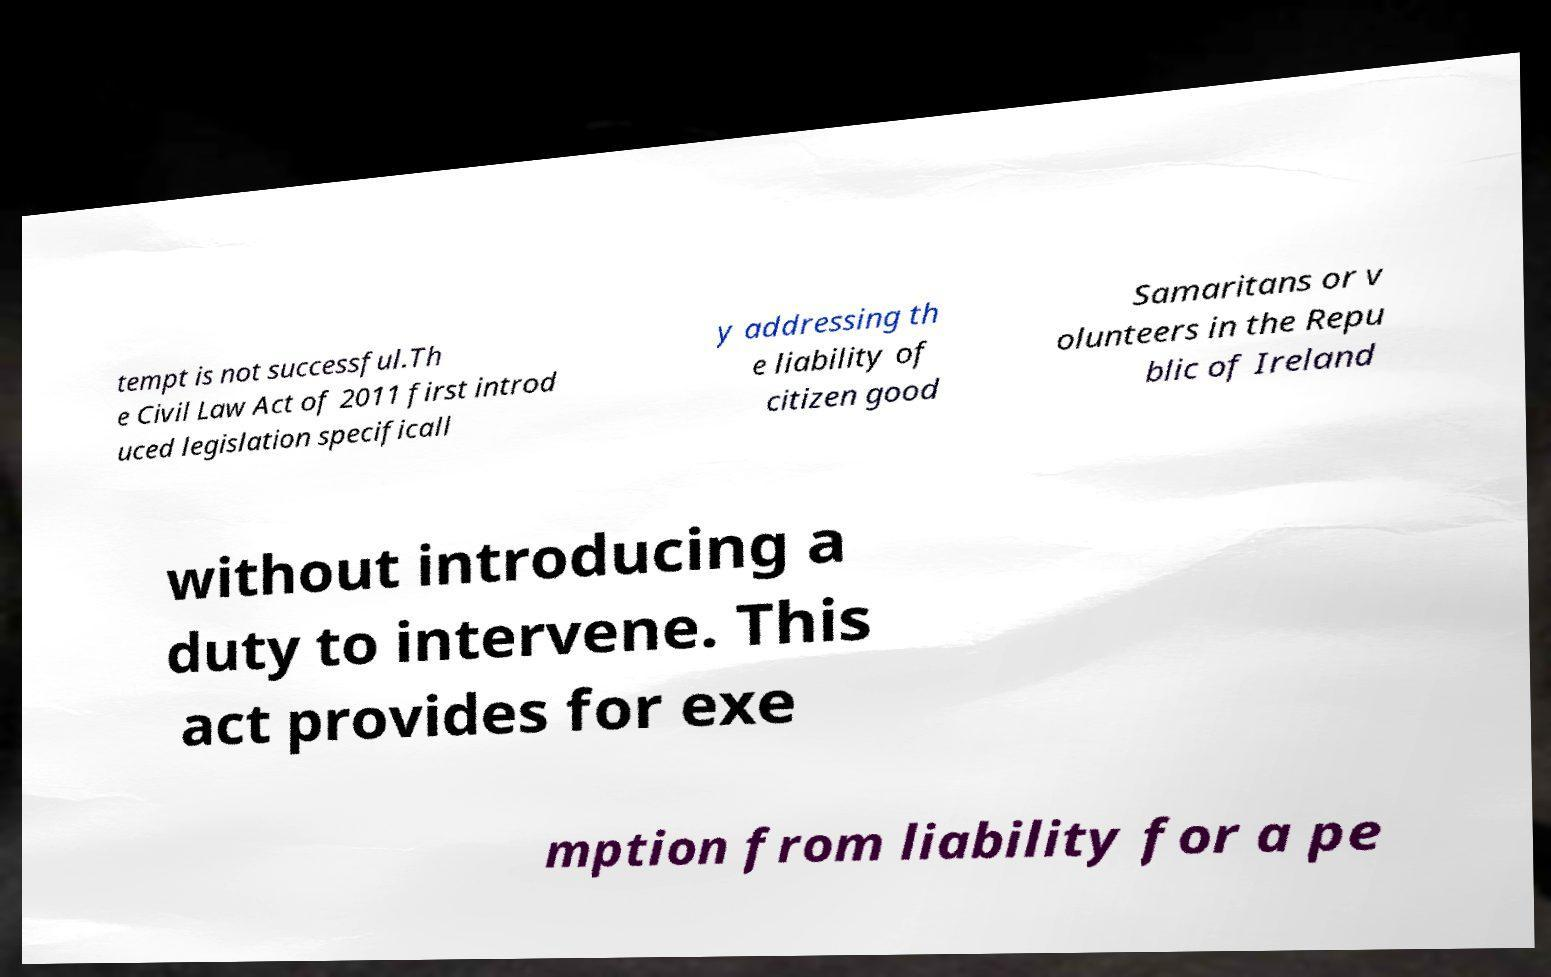I need the written content from this picture converted into text. Can you do that? tempt is not successful.Th e Civil Law Act of 2011 first introd uced legislation specificall y addressing th e liability of citizen good Samaritans or v olunteers in the Repu blic of Ireland without introducing a duty to intervene. This act provides for exe mption from liability for a pe 